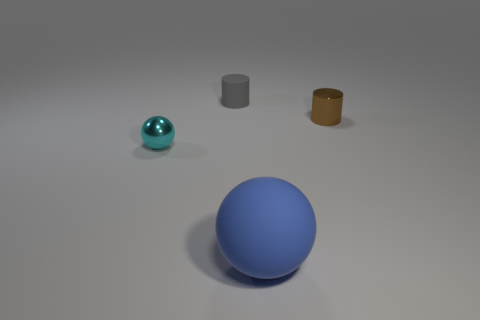Subtract all brown cylinders. How many cylinders are left? 1 Subtract 0 yellow blocks. How many objects are left? 4 Subtract 1 cylinders. How many cylinders are left? 1 Subtract all purple spheres. Subtract all gray cubes. How many spheres are left? 2 Subtract all green cylinders. How many yellow spheres are left? 0 Subtract all small yellow shiny objects. Subtract all small gray matte cylinders. How many objects are left? 3 Add 1 large matte balls. How many large matte balls are left? 2 Add 1 tiny cylinders. How many tiny cylinders exist? 3 Add 1 tiny brown metal objects. How many objects exist? 5 